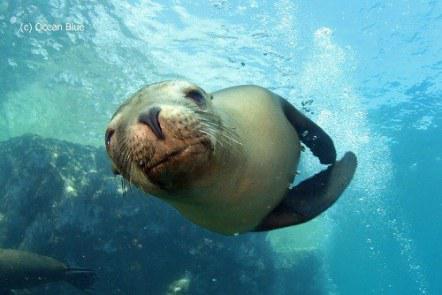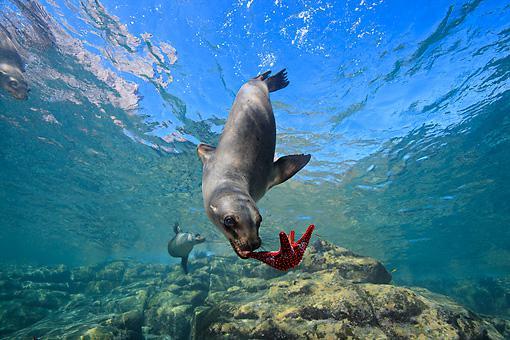The first image is the image on the left, the second image is the image on the right. Assess this claim about the two images: "The left image contains no more than one seal.". Correct or not? Answer yes or no. Yes. The first image is the image on the left, the second image is the image on the right. Examine the images to the left and right. Is the description "An image shows a seal with its nose close to the camera, and no image contains more than one seal in the foreground." accurate? Answer yes or no. Yes. 